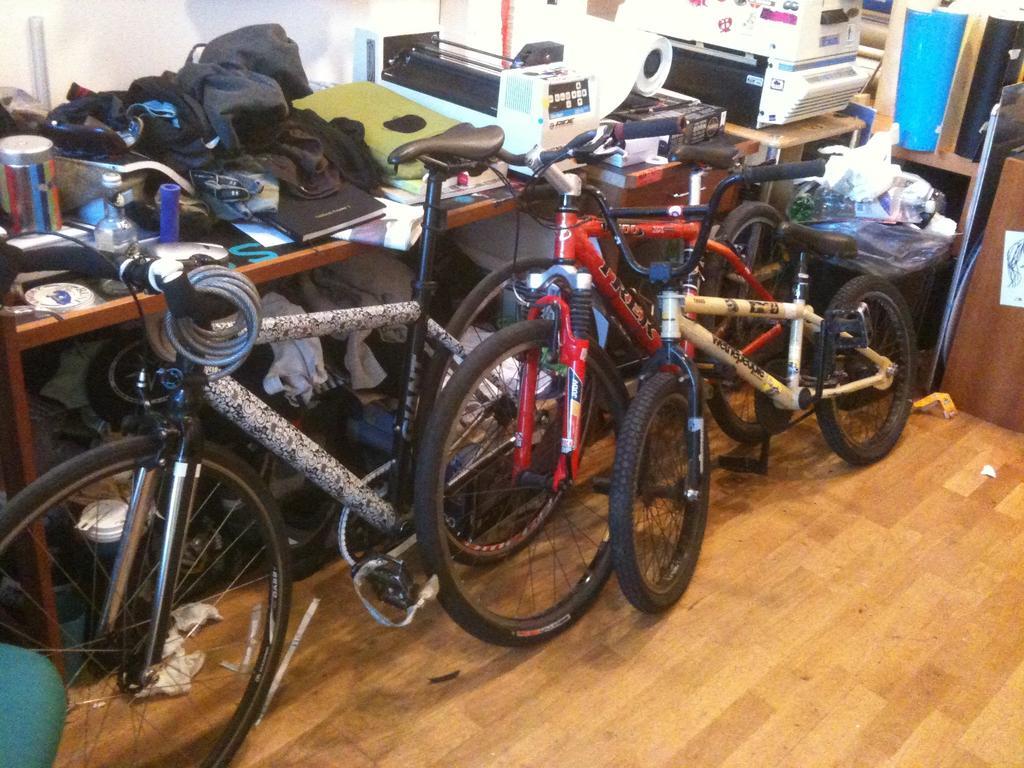Could you give a brief overview of what you see in this image? In this image, we can see few bicycles are on the wooden surface. Background we can see tablecloths, few objects, machines and things. 